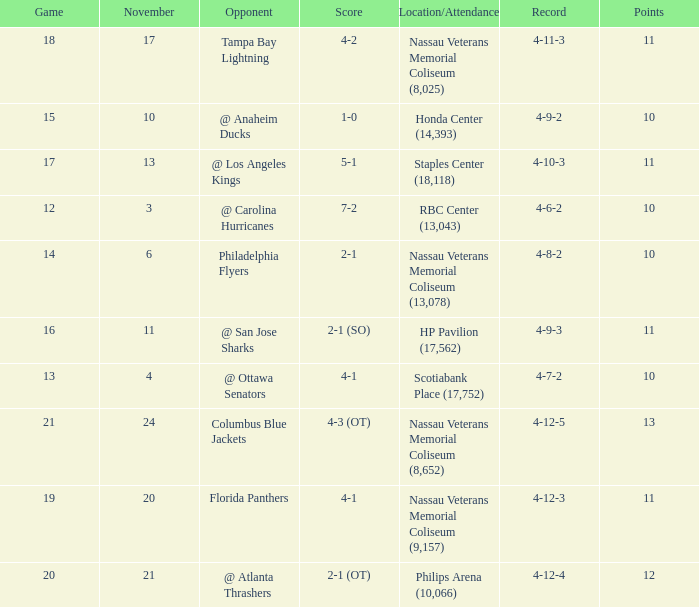What is the least amount of points? 10.0. Help me parse the entirety of this table. {'header': ['Game', 'November', 'Opponent', 'Score', 'Location/Attendance', 'Record', 'Points'], 'rows': [['18', '17', 'Tampa Bay Lightning', '4-2', 'Nassau Veterans Memorial Coliseum (8,025)', '4-11-3', '11'], ['15', '10', '@ Anaheim Ducks', '1-0', 'Honda Center (14,393)', '4-9-2', '10'], ['17', '13', '@ Los Angeles Kings', '5-1', 'Staples Center (18,118)', '4-10-3', '11'], ['12', '3', '@ Carolina Hurricanes', '7-2', 'RBC Center (13,043)', '4-6-2', '10'], ['14', '6', 'Philadelphia Flyers', '2-1', 'Nassau Veterans Memorial Coliseum (13,078)', '4-8-2', '10'], ['16', '11', '@ San Jose Sharks', '2-1 (SO)', 'HP Pavilion (17,562)', '4-9-3', '11'], ['13', '4', '@ Ottawa Senators', '4-1', 'Scotiabank Place (17,752)', '4-7-2', '10'], ['21', '24', 'Columbus Blue Jackets', '4-3 (OT)', 'Nassau Veterans Memorial Coliseum (8,652)', '4-12-5', '13'], ['19', '20', 'Florida Panthers', '4-1', 'Nassau Veterans Memorial Coliseum (9,157)', '4-12-3', '11'], ['20', '21', '@ Atlanta Thrashers', '2-1 (OT)', 'Philips Arena (10,066)', '4-12-4', '12']]} 